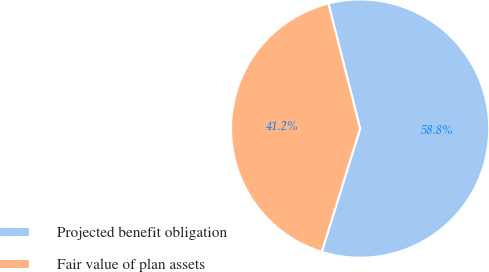Convert chart. <chart><loc_0><loc_0><loc_500><loc_500><pie_chart><fcel>Projected benefit obligation<fcel>Fair value of plan assets<nl><fcel>58.76%<fcel>41.24%<nl></chart> 